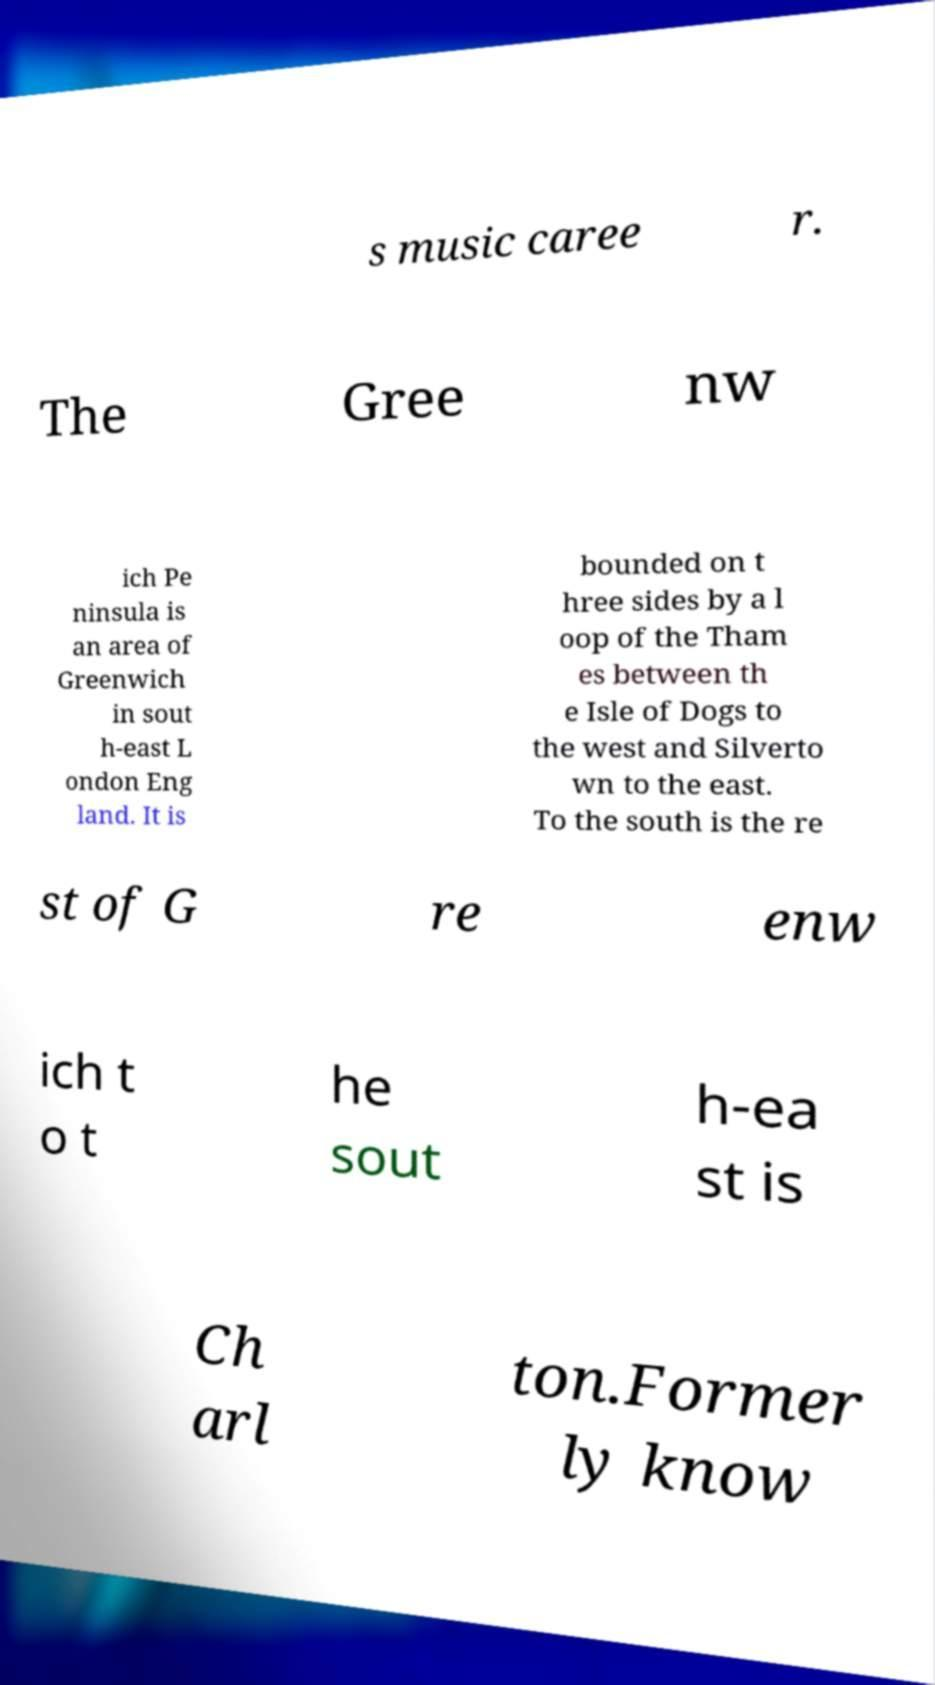What messages or text are displayed in this image? I need them in a readable, typed format. s music caree r. The Gree nw ich Pe ninsula is an area of Greenwich in sout h-east L ondon Eng land. It is bounded on t hree sides by a l oop of the Tham es between th e Isle of Dogs to the west and Silverto wn to the east. To the south is the re st of G re enw ich t o t he sout h-ea st is Ch arl ton.Former ly know 